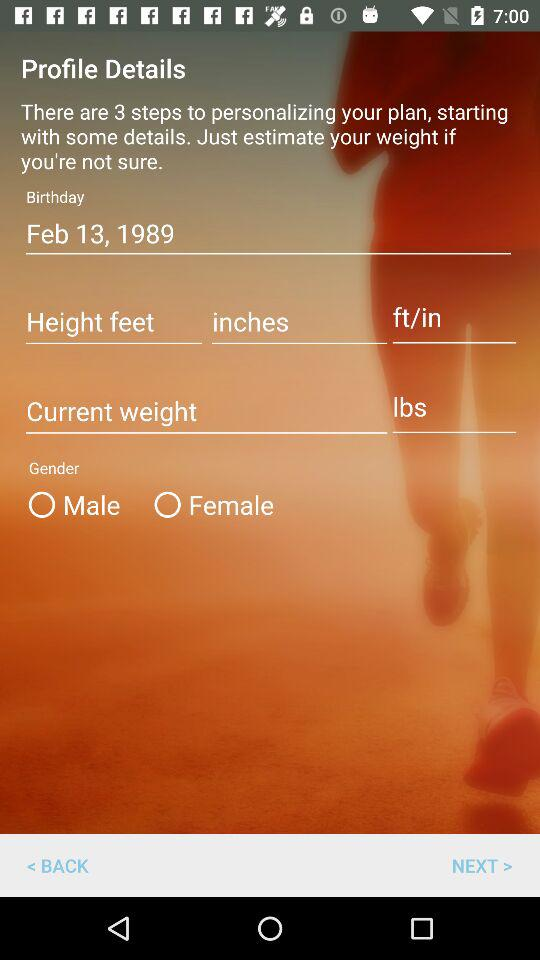How tall is the user?
When the provided information is insufficient, respond with <no answer>. <no answer> 